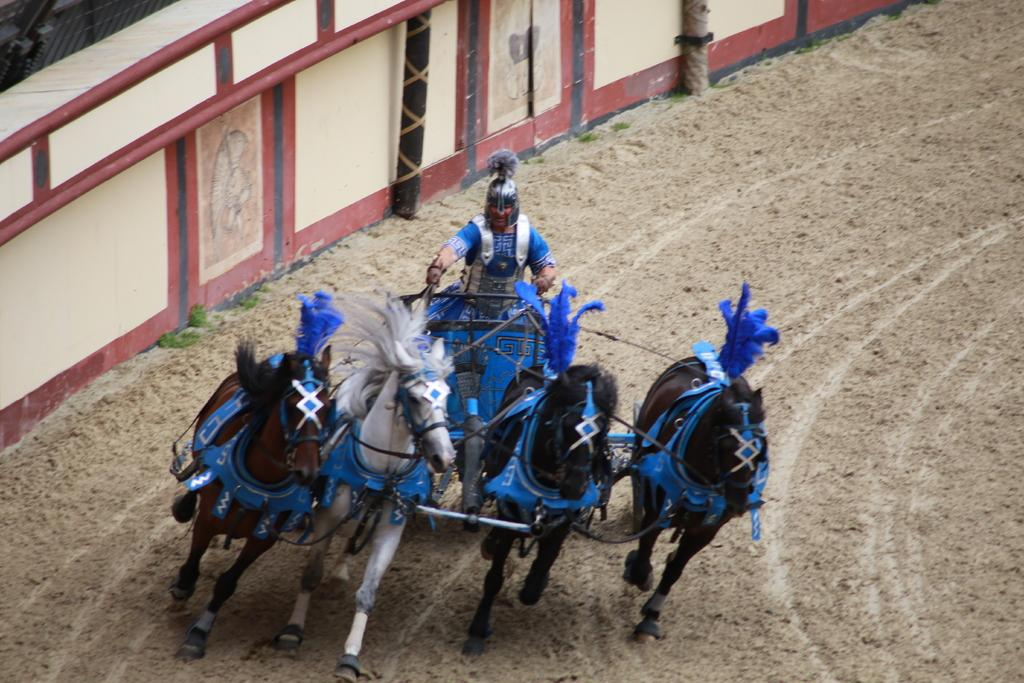Who is present in the image? There is a man in the image. What is the man doing in the image? The man is sitting on a horse cart. What type of terrain is visible at the bottom of the image? There is sand at the bottom of the image. What can be seen in the background of the image? There is a wall in the background of the image. What is the purpose of the army in the image? There is no army present in the image; it features a man sitting on a horse cart with a wall in the background. 